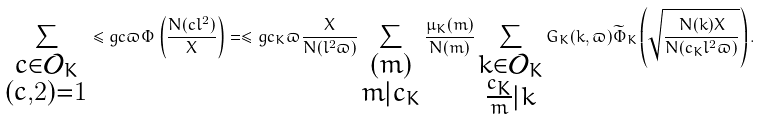Convert formula to latex. <formula><loc_0><loc_0><loc_500><loc_500>\sum _ { \substack { c \in \mathcal { O } _ { K } \\ ( c , 2 ) = 1 } } \leq g { c } { \varpi } \Phi \left ( \frac { N ( c l ^ { 2 } ) } { X } \right ) = \leq g { c _ { K } } { \varpi } \frac { X } { N ( l ^ { 2 } \varpi ) } \sum _ { \substack { ( m ) \\ m | c _ { K } } } \frac { \mu _ { K } ( m ) } { N ( m ) } \sum _ { \substack { k \in \mathcal { O } _ { K } \\ \frac { c _ { K } } { m } | k } } G _ { K } ( k , \varpi ) \widetilde { \Phi } _ { K } \left ( \sqrt { \frac { N ( k ) X } { N ( c _ { K } l ^ { 2 } \varpi ) } } \right ) .</formula> 